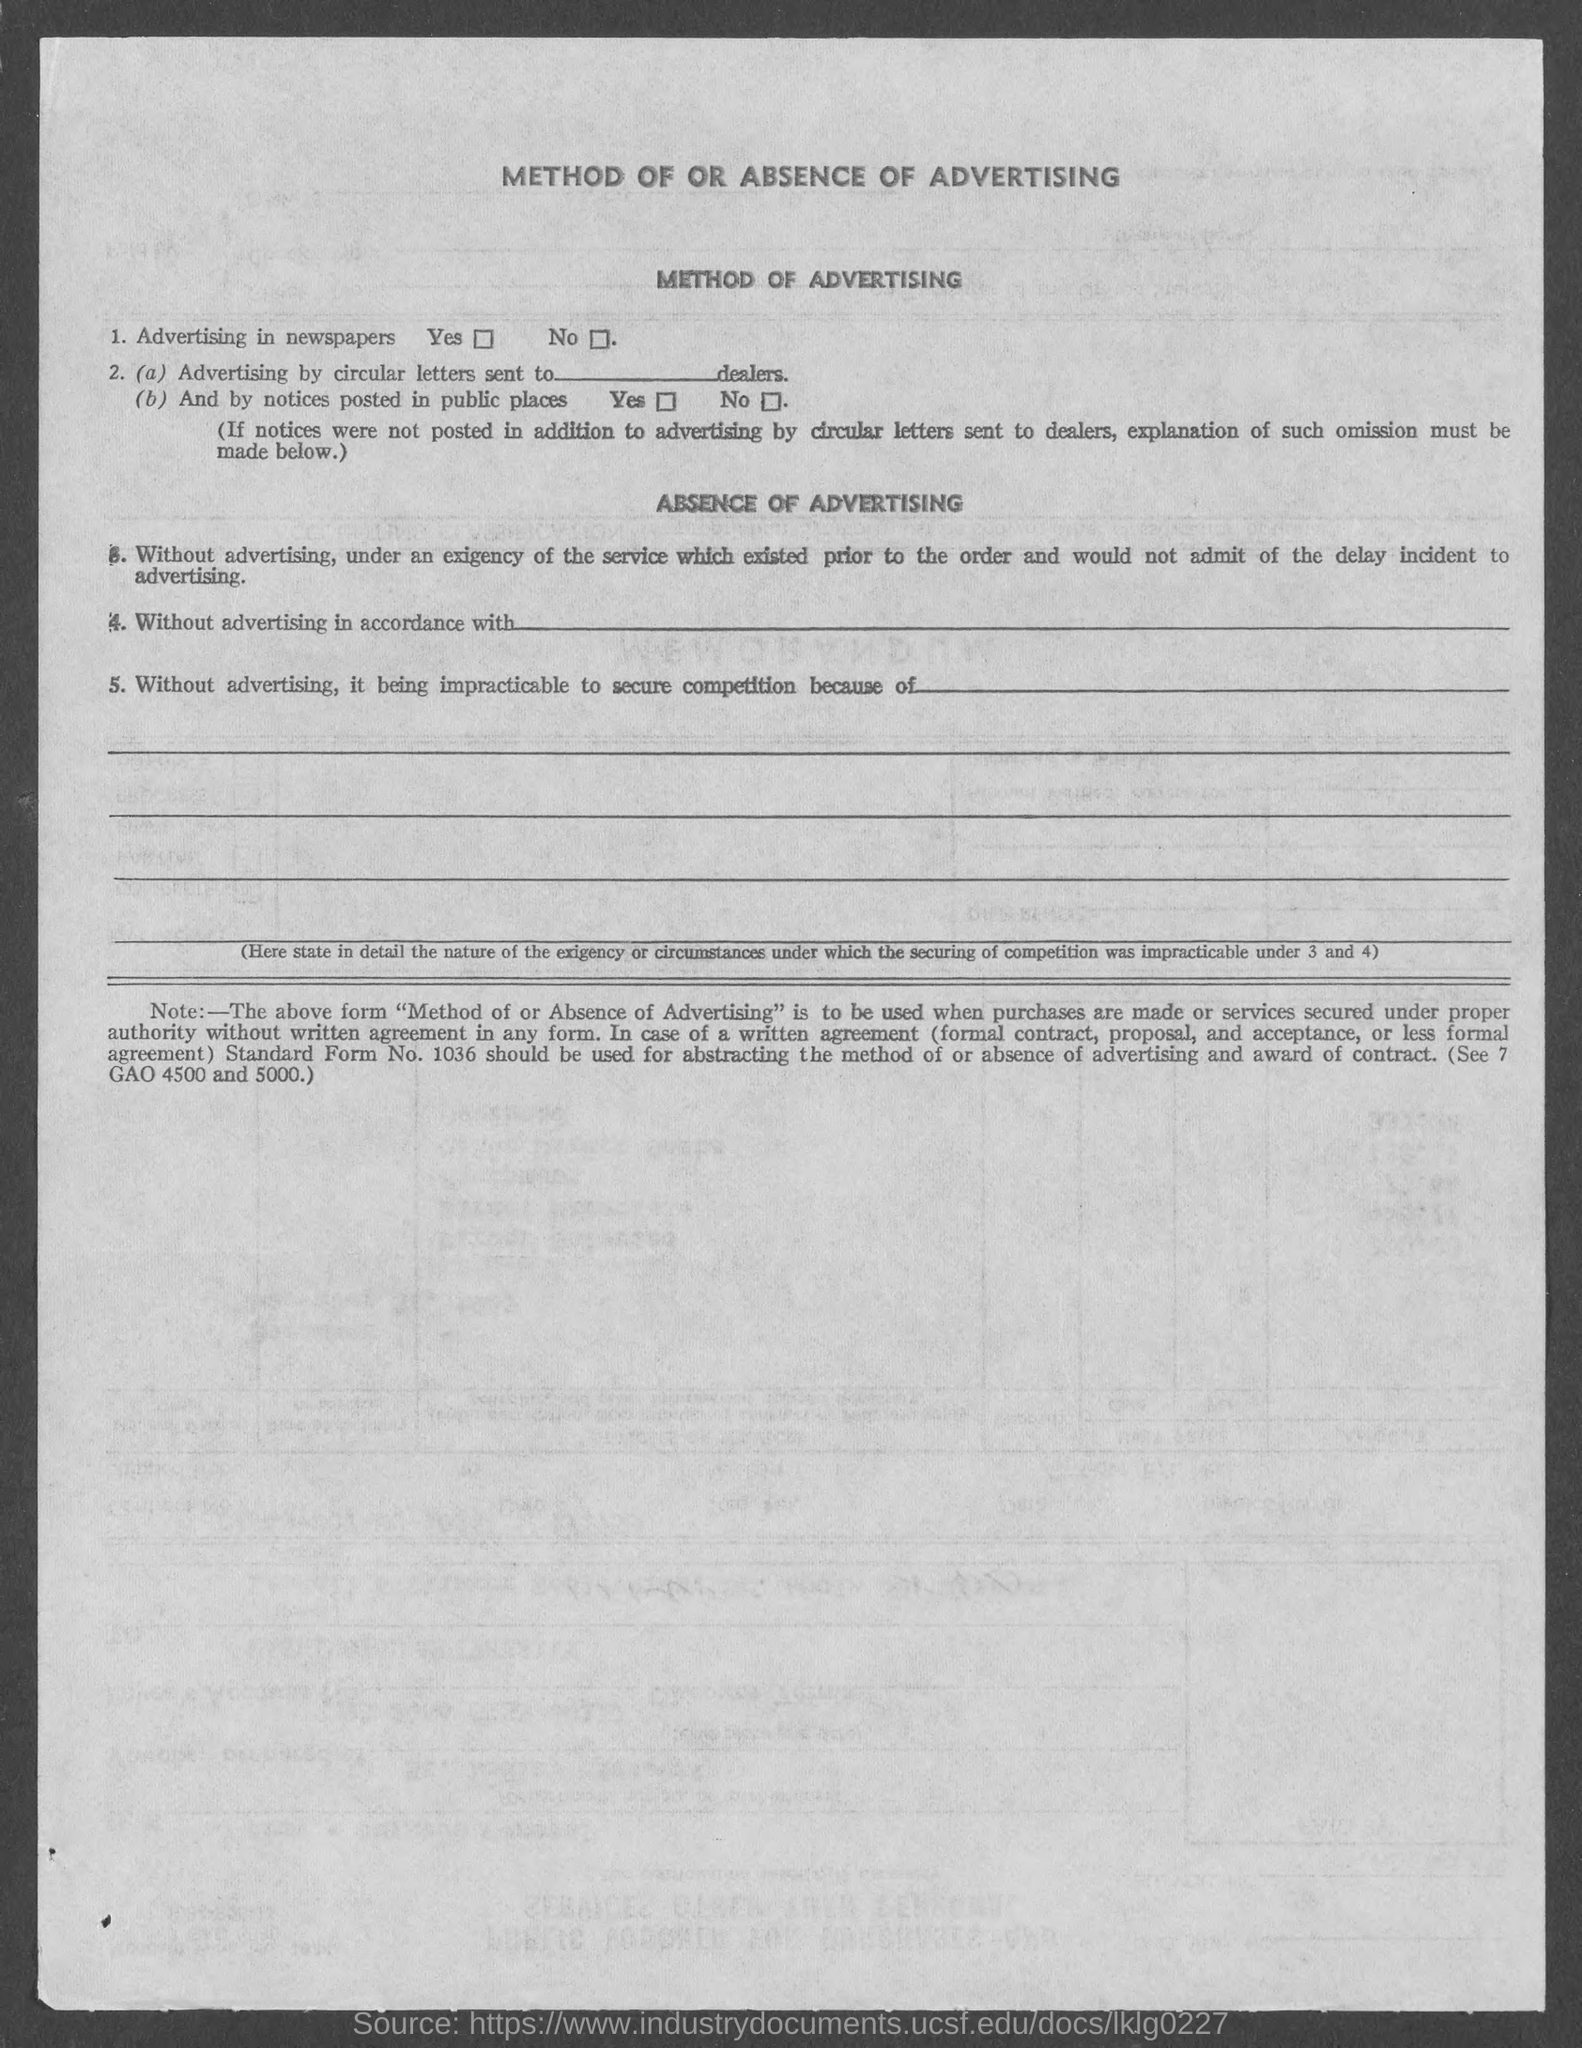Identify some key points in this picture. The heading of the page asks the question of whether or not advertising is present. 